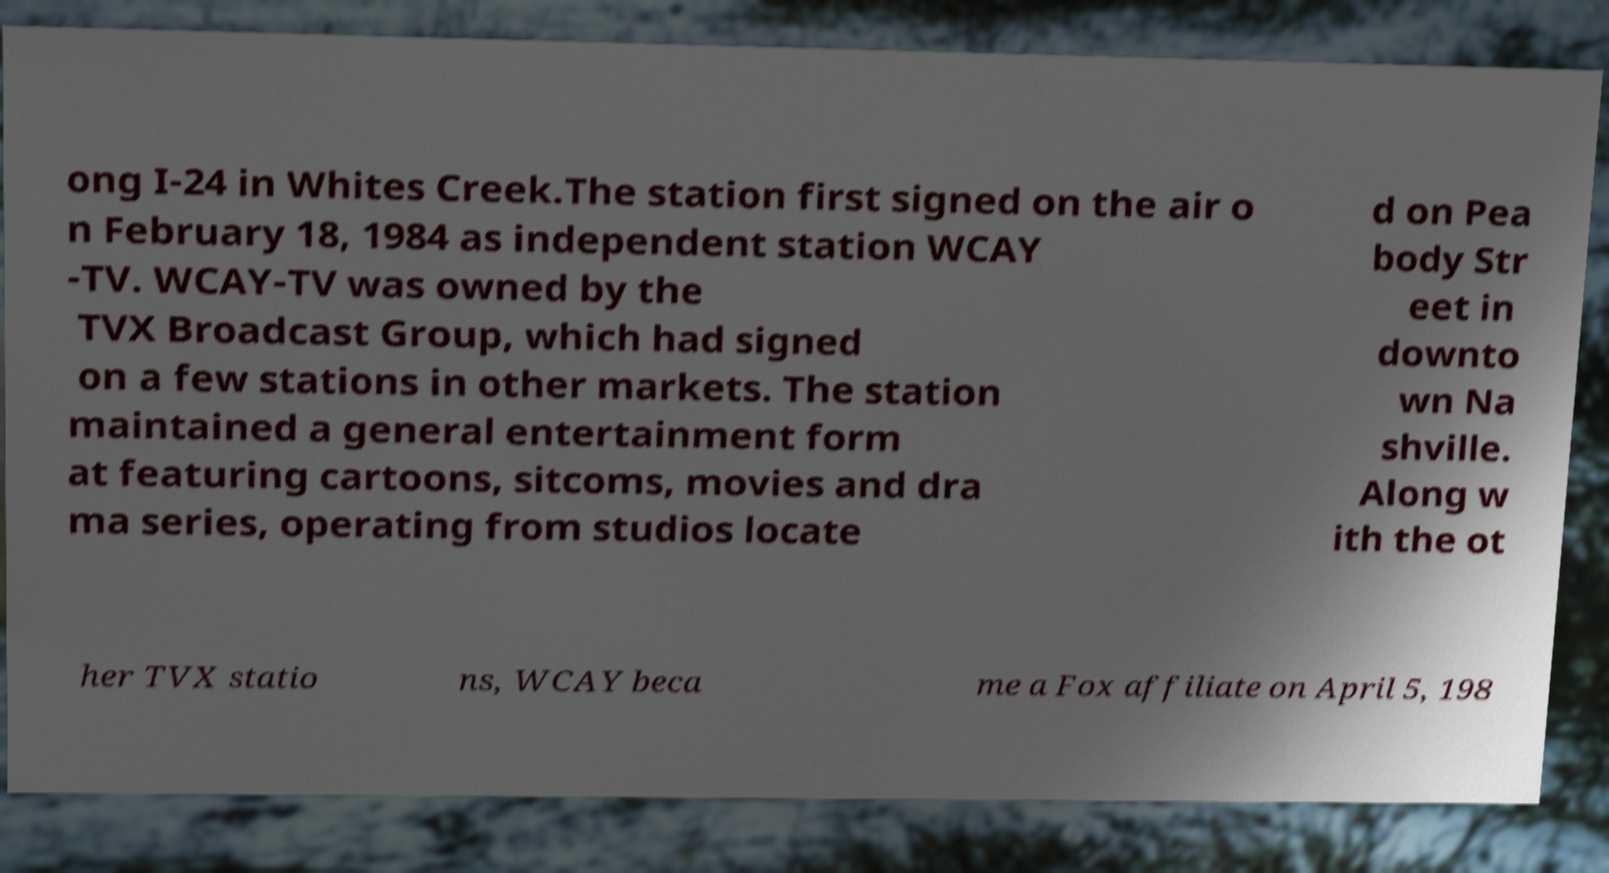Can you accurately transcribe the text from the provided image for me? ong I-24 in Whites Creek.The station first signed on the air o n February 18, 1984 as independent station WCAY -TV. WCAY-TV was owned by the TVX Broadcast Group, which had signed on a few stations in other markets. The station maintained a general entertainment form at featuring cartoons, sitcoms, movies and dra ma series, operating from studios locate d on Pea body Str eet in downto wn Na shville. Along w ith the ot her TVX statio ns, WCAY beca me a Fox affiliate on April 5, 198 